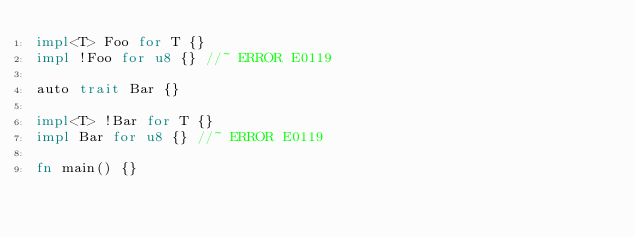<code> <loc_0><loc_0><loc_500><loc_500><_Rust_>impl<T> Foo for T {}
impl !Foo for u8 {} //~ ERROR E0119

auto trait Bar {}

impl<T> !Bar for T {}
impl Bar for u8 {} //~ ERROR E0119

fn main() {}
</code> 